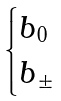<formula> <loc_0><loc_0><loc_500><loc_500>\begin{cases} b _ { 0 } \\ b _ { \pm } \end{cases}</formula> 